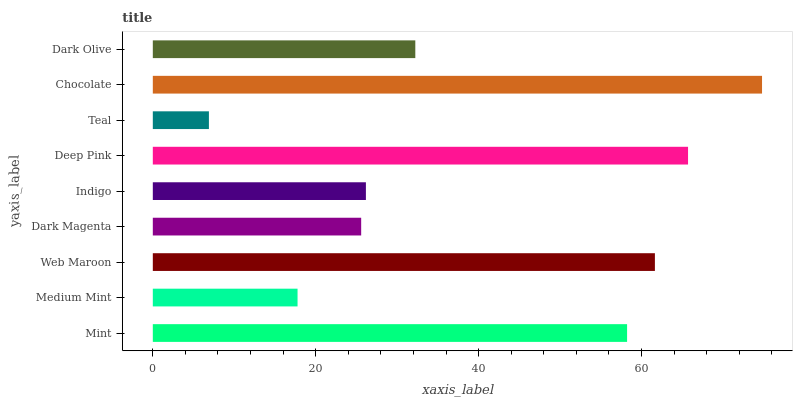Is Teal the minimum?
Answer yes or no. Yes. Is Chocolate the maximum?
Answer yes or no. Yes. Is Medium Mint the minimum?
Answer yes or no. No. Is Medium Mint the maximum?
Answer yes or no. No. Is Mint greater than Medium Mint?
Answer yes or no. Yes. Is Medium Mint less than Mint?
Answer yes or no. Yes. Is Medium Mint greater than Mint?
Answer yes or no. No. Is Mint less than Medium Mint?
Answer yes or no. No. Is Dark Olive the high median?
Answer yes or no. Yes. Is Dark Olive the low median?
Answer yes or no. Yes. Is Teal the high median?
Answer yes or no. No. Is Dark Magenta the low median?
Answer yes or no. No. 